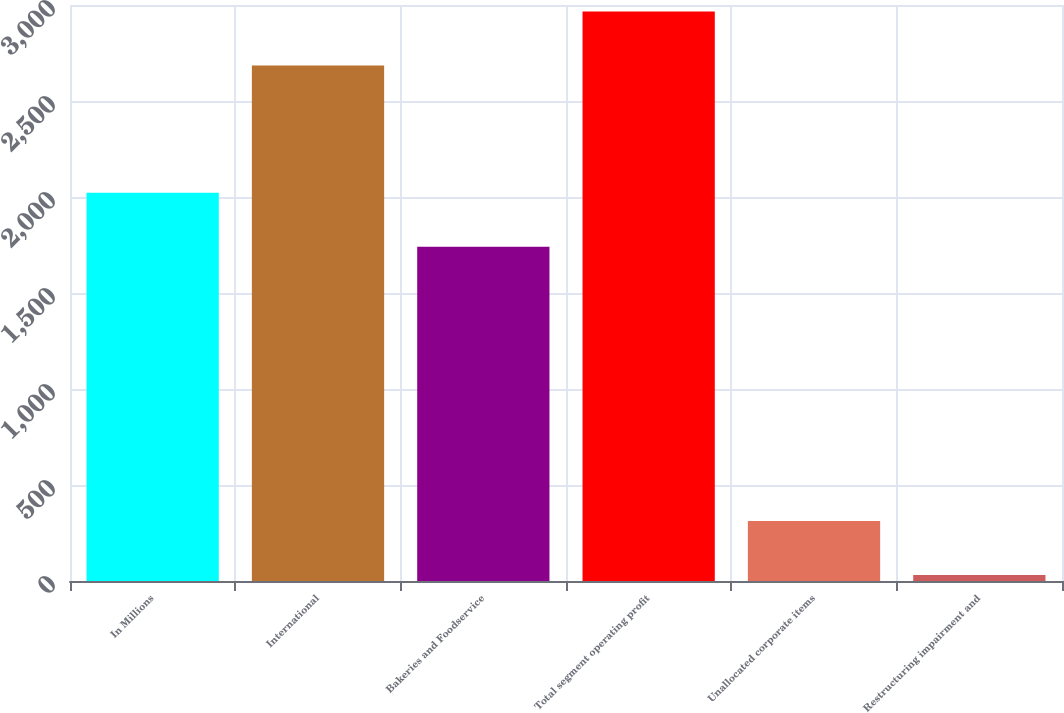Convert chart to OTSL. <chart><loc_0><loc_0><loc_500><loc_500><bar_chart><fcel>In Millions<fcel>International<fcel>Bakeries and Foodservice<fcel>Total segment operating profit<fcel>Unallocated corporate items<fcel>Restructuring impairment and<nl><fcel>2021.81<fcel>2684.9<fcel>1740.9<fcel>2965.81<fcel>312.31<fcel>31.4<nl></chart> 